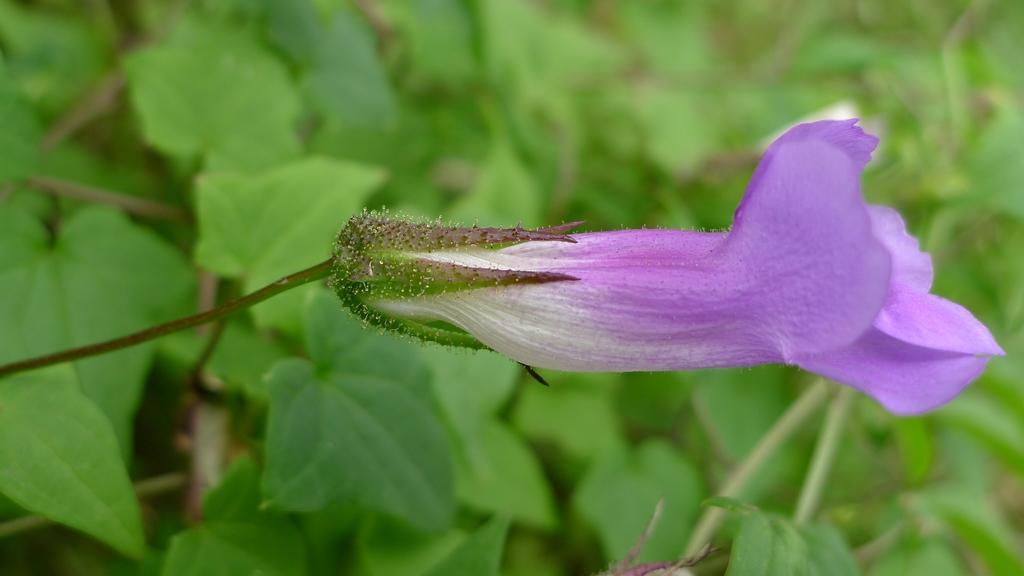In one or two sentences, can you explain what this image depicts? In this image, we can see a flower with stem. Background there is a blur view. Here we can see greenery. 